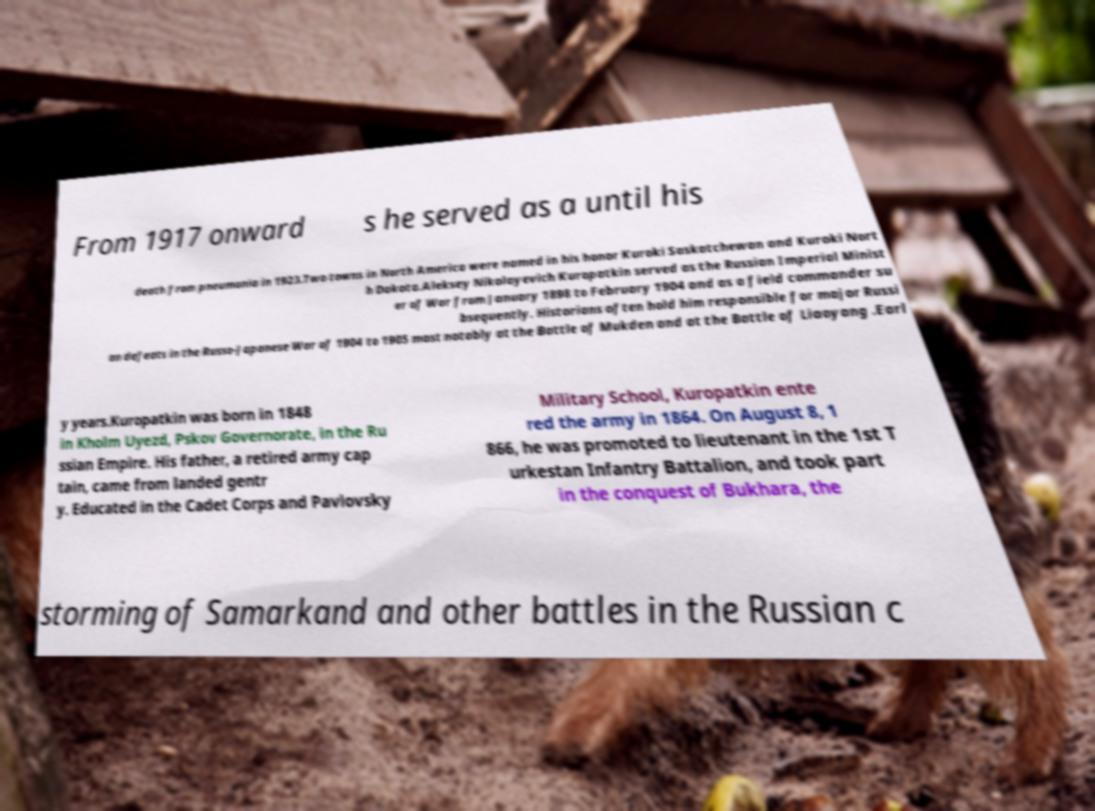Can you read and provide the text displayed in the image?This photo seems to have some interesting text. Can you extract and type it out for me? From 1917 onward s he served as a until his death from pneumonia in 1923.Two towns in North America were named in his honor Kuroki Saskatchewan and Kuroki Nort h Dakota.Aleksey Nikolayevich Kuropatkin served as the Russian Imperial Minist er of War from January 1898 to February 1904 and as a field commander su bsequently. Historians often hold him responsible for major Russi an defeats in the Russo-Japanese War of 1904 to 1905 most notably at the Battle of Mukden and at the Battle of Liaoyang .Earl y years.Kuropatkin was born in 1848 in Kholm Uyezd, Pskov Governorate, in the Ru ssian Empire. His father, a retired army cap tain, came from landed gentr y. Educated in the Cadet Corps and Pavlovsky Military School, Kuropatkin ente red the army in 1864. On August 8, 1 866, he was promoted to lieutenant in the 1st T urkestan Infantry Battalion, and took part in the conquest of Bukhara, the storming of Samarkand and other battles in the Russian c 